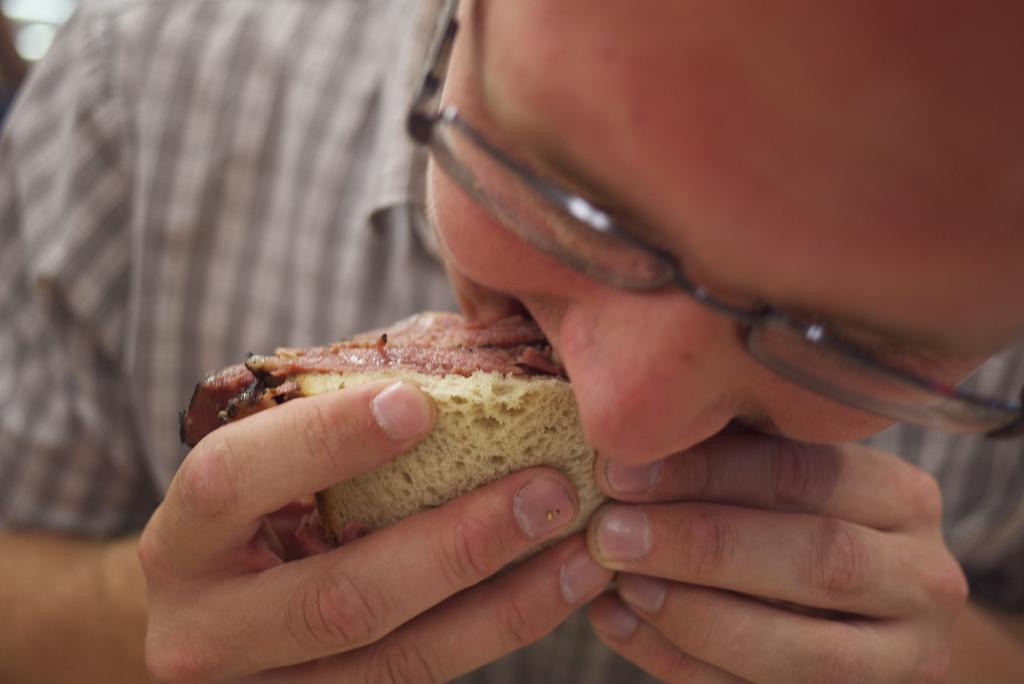Who is the person in the image? There is a man in the image. What is the man doing in the image? The man is eating a sandwich. What type of leather is the man using to hold the sandwich in the image? There is no leather present in the image, and the man is not using any leather to hold the sandwich. 